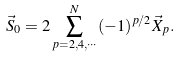<formula> <loc_0><loc_0><loc_500><loc_500>\vec { S } _ { 0 } = 2 \sum ^ { N } _ { p = 2 , 4 , \cdots } ( - 1 ) ^ { p / 2 } \vec { X } _ { p } .</formula> 